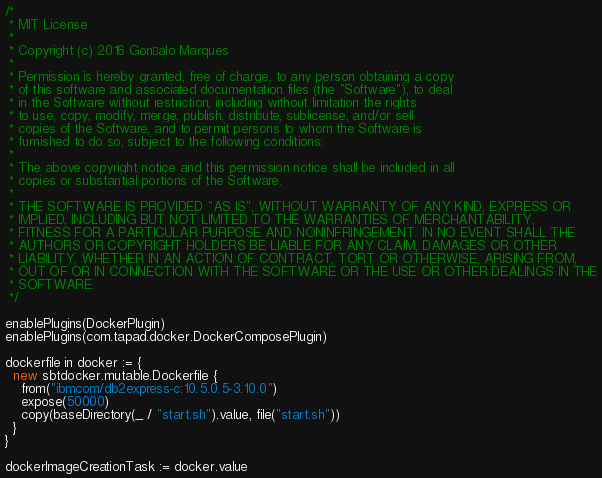Convert code to text. <code><loc_0><loc_0><loc_500><loc_500><_Scala_>/*
 * MIT License
 *
 * Copyright (c) 2016 Gonçalo Marques
 *
 * Permission is hereby granted, free of charge, to any person obtaining a copy
 * of this software and associated documentation files (the "Software"), to deal
 * in the Software without restriction, including without limitation the rights
 * to use, copy, modify, merge, publish, distribute, sublicense, and/or sell
 * copies of the Software, and to permit persons to whom the Software is
 * furnished to do so, subject to the following conditions:
 *
 * The above copyright notice and this permission notice shall be included in all
 * copies or substantial portions of the Software.
 *
 * THE SOFTWARE IS PROVIDED "AS IS", WITHOUT WARRANTY OF ANY KIND, EXPRESS OR
 * IMPLIED, INCLUDING BUT NOT LIMITED TO THE WARRANTIES OF MERCHANTABILITY,
 * FITNESS FOR A PARTICULAR PURPOSE AND NONINFRINGEMENT. IN NO EVENT SHALL THE
 * AUTHORS OR COPYRIGHT HOLDERS BE LIABLE FOR ANY CLAIM, DAMAGES OR OTHER
 * LIABILITY, WHETHER IN AN ACTION OF CONTRACT, TORT OR OTHERWISE, ARISING FROM,
 * OUT OF OR IN CONNECTION WITH THE SOFTWARE OR THE USE OR OTHER DEALINGS IN THE
 * SOFTWARE.
 */

enablePlugins(DockerPlugin)
enablePlugins(com.tapad.docker.DockerComposePlugin)

dockerfile in docker := {
  new sbtdocker.mutable.Dockerfile {
    from("ibmcom/db2express-c:10.5.0.5-3.10.0")
    expose(50000)
    copy(baseDirectory(_ / "start.sh").value, file("start.sh"))
  }
}

dockerImageCreationTask := docker.value
</code> 